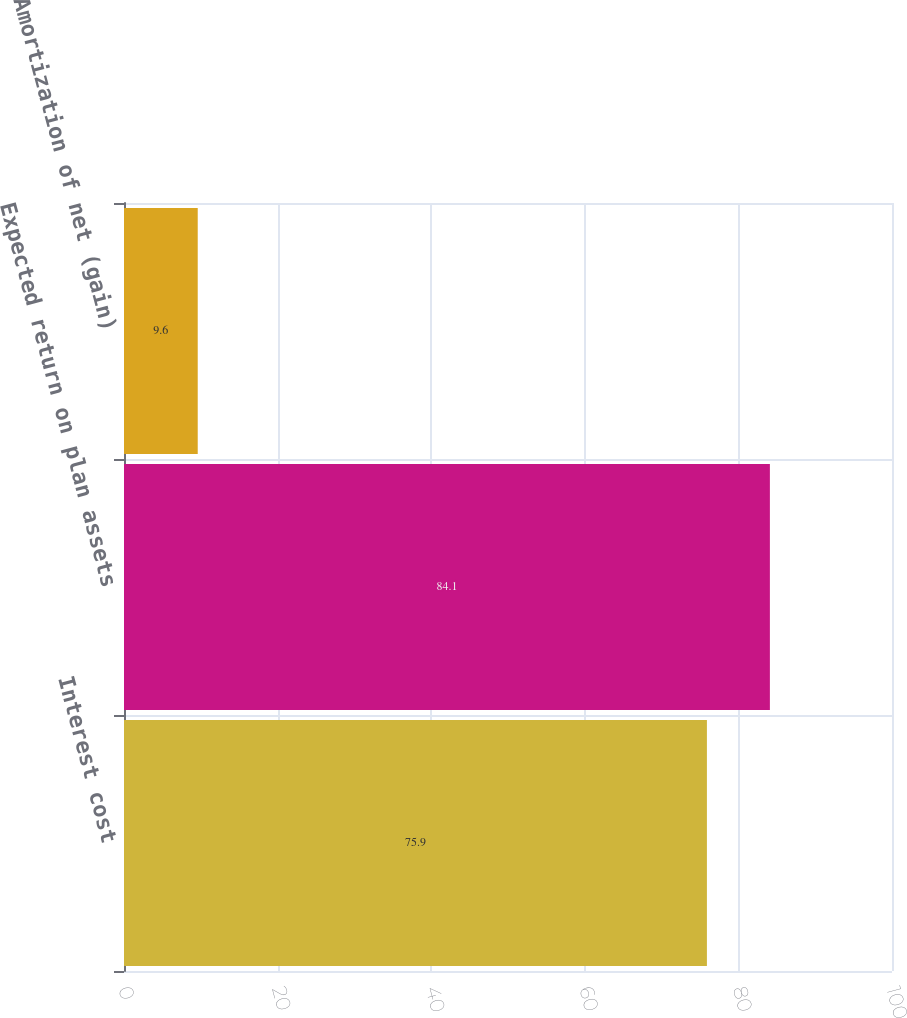Convert chart to OTSL. <chart><loc_0><loc_0><loc_500><loc_500><bar_chart><fcel>Interest cost<fcel>Expected return on plan assets<fcel>Amortization of net (gain)<nl><fcel>75.9<fcel>84.1<fcel>9.6<nl></chart> 